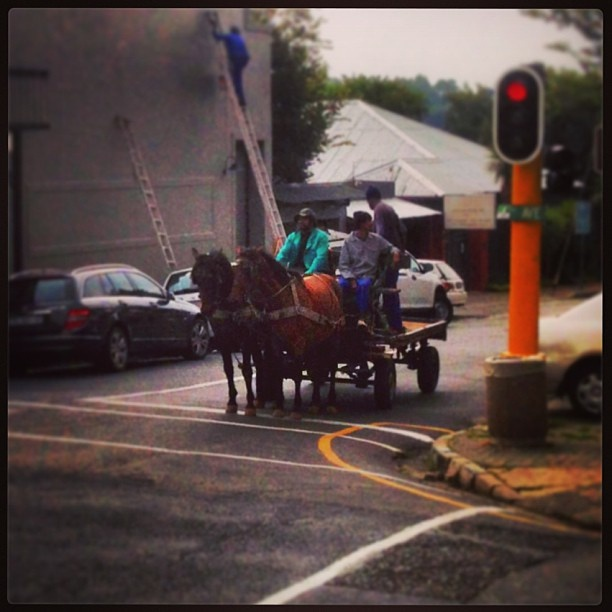Describe the objects in this image and their specific colors. I can see car in black, gray, darkgray, and maroon tones, horse in black, maroon, and brown tones, car in black and tan tones, horse in black, gray, and darkgray tones, and traffic light in black, gray, maroon, and brown tones in this image. 